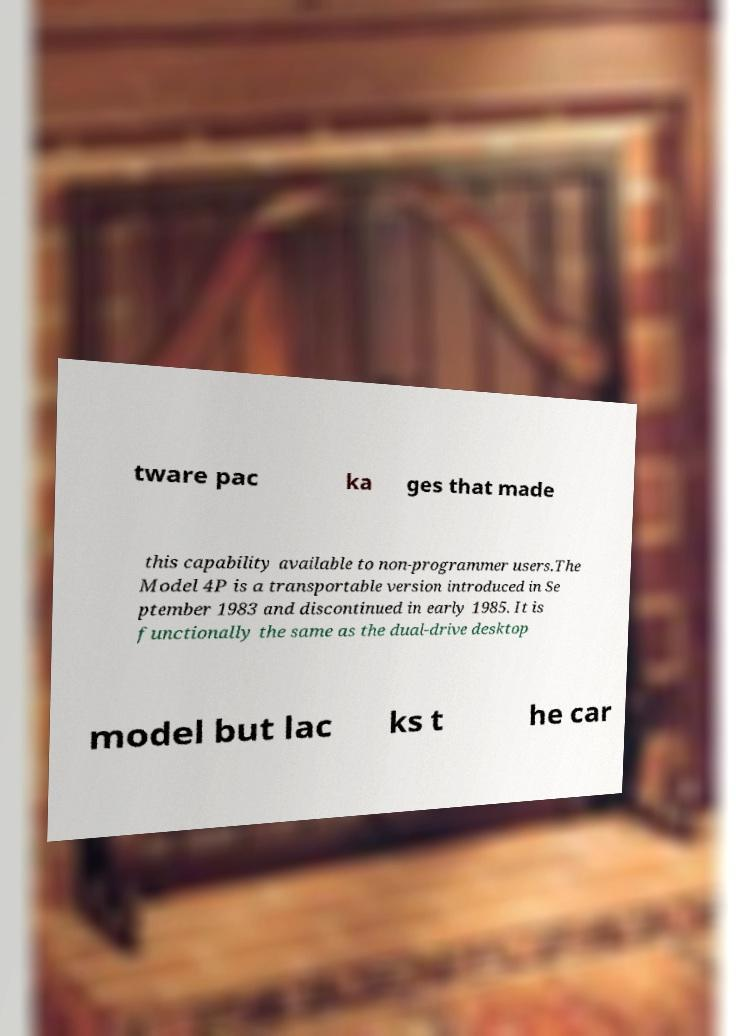Can you read and provide the text displayed in the image?This photo seems to have some interesting text. Can you extract and type it out for me? tware pac ka ges that made this capability available to non-programmer users.The Model 4P is a transportable version introduced in Se ptember 1983 and discontinued in early 1985. It is functionally the same as the dual-drive desktop model but lac ks t he car 